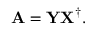<formula> <loc_0><loc_0><loc_500><loc_500>{ A } = { Y } { X } ^ { \dagger } .</formula> 